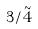Convert formula to latex. <formula><loc_0><loc_0><loc_500><loc_500>3 / \tilde { 4 }</formula> 